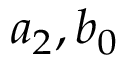<formula> <loc_0><loc_0><loc_500><loc_500>a _ { 2 } , b _ { 0 }</formula> 